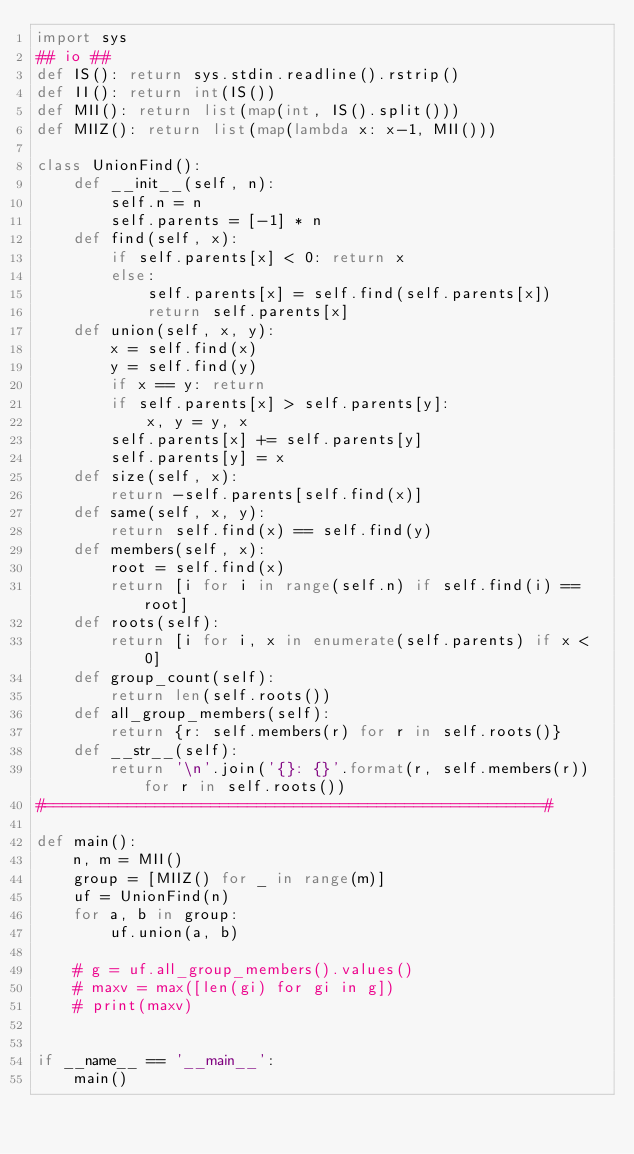Convert code to text. <code><loc_0><loc_0><loc_500><loc_500><_Python_>import sys
## io ##
def IS(): return sys.stdin.readline().rstrip()
def II(): return int(IS())
def MII(): return list(map(int, IS().split()))
def MIIZ(): return list(map(lambda x: x-1, MII()))

class UnionFind():
    def __init__(self, n):
        self.n = n
        self.parents = [-1] * n
    def find(self, x):
        if self.parents[x] < 0: return x
        else:
            self.parents[x] = self.find(self.parents[x])
            return self.parents[x]
    def union(self, x, y):
        x = self.find(x)
        y = self.find(y)
        if x == y: return
        if self.parents[x] > self.parents[y]:
            x, y = y, x
        self.parents[x] += self.parents[y]
        self.parents[y] = x
    def size(self, x):
        return -self.parents[self.find(x)]
    def same(self, x, y):
        return self.find(x) == self.find(y)
    def members(self, x):
        root = self.find(x)
        return [i for i in range(self.n) if self.find(i) == root]
    def roots(self):
        return [i for i, x in enumerate(self.parents) if x < 0]
    def group_count(self):
        return len(self.roots())
    def all_group_members(self):
        return {r: self.members(r) for r in self.roots()}
    def __str__(self):
        return '\n'.join('{}: {}'.format(r, self.members(r)) for r in self.roots())
#======================================================#

def main():
    n, m = MII()
    group = [MIIZ() for _ in range(m)]
    uf = UnionFind(n)
    for a, b in group:
        uf.union(a, b)

    # g = uf.all_group_members().values()
    # maxv = max([len(gi) for gi in g])
    # print(maxv)


if __name__ == '__main__':
    main()</code> 